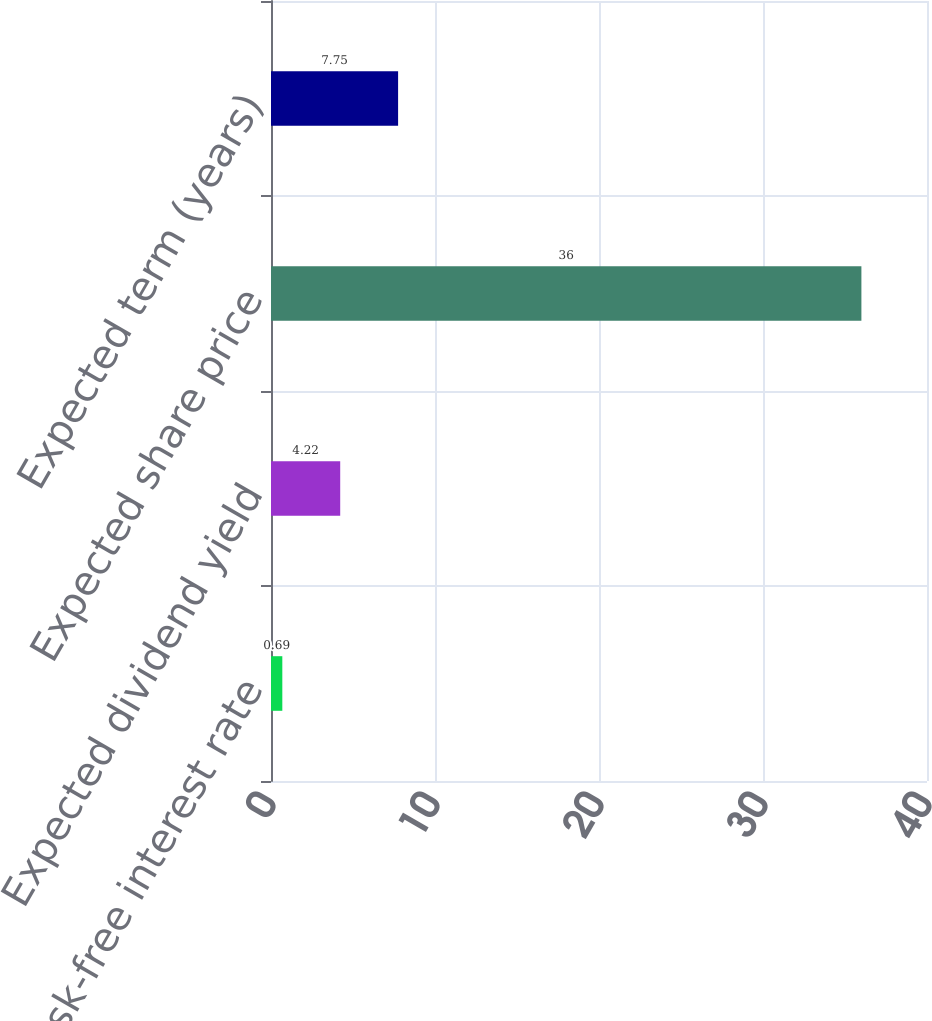Convert chart to OTSL. <chart><loc_0><loc_0><loc_500><loc_500><bar_chart><fcel>Risk-free interest rate<fcel>Expected dividend yield<fcel>Expected share price<fcel>Expected term (years)<nl><fcel>0.69<fcel>4.22<fcel>36<fcel>7.75<nl></chart> 